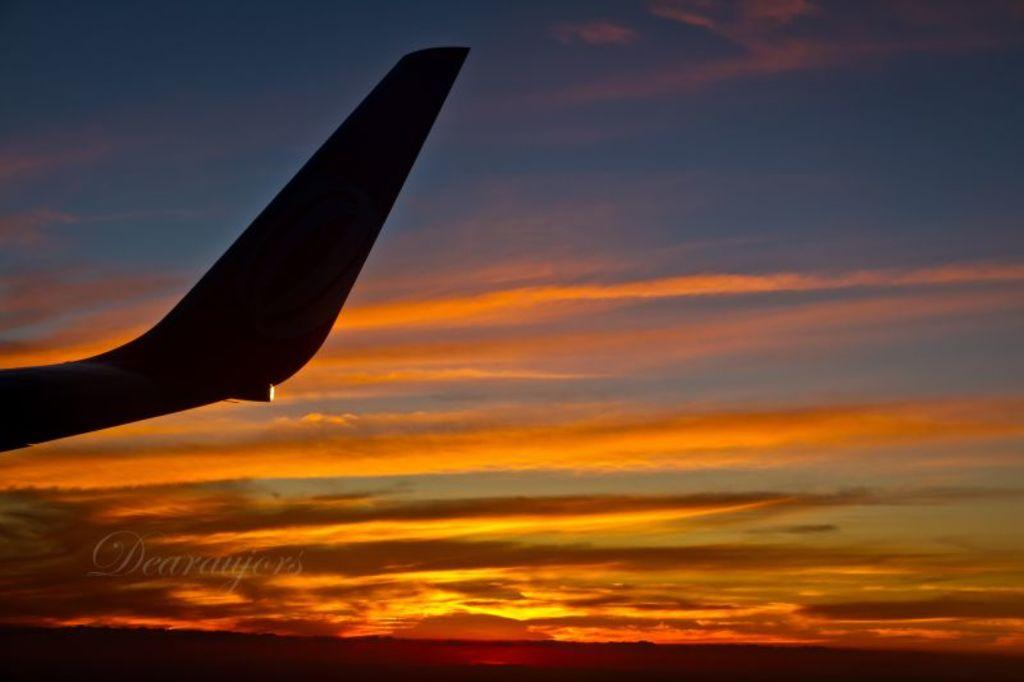<image>
Render a clear and concise summary of the photo. a plane tail is shadowed in front of a beautiful sky, taken by Dearaujres 